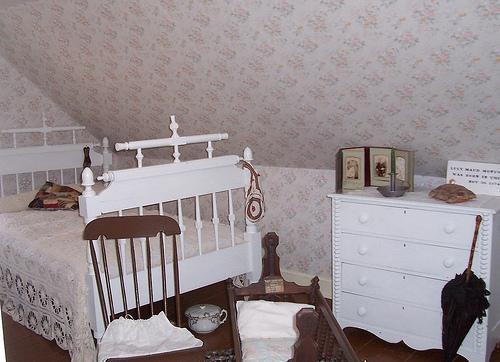How many chairs are in the picture?
Give a very brief answer. 1. 